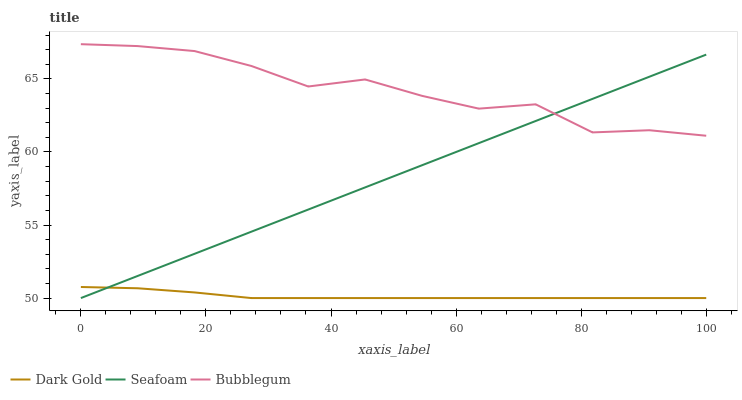Does Dark Gold have the minimum area under the curve?
Answer yes or no. Yes. Does Bubblegum have the maximum area under the curve?
Answer yes or no. Yes. Does Bubblegum have the minimum area under the curve?
Answer yes or no. No. Does Dark Gold have the maximum area under the curve?
Answer yes or no. No. Is Seafoam the smoothest?
Answer yes or no. Yes. Is Bubblegum the roughest?
Answer yes or no. Yes. Is Dark Gold the smoothest?
Answer yes or no. No. Is Dark Gold the roughest?
Answer yes or no. No. Does Seafoam have the lowest value?
Answer yes or no. Yes. Does Bubblegum have the lowest value?
Answer yes or no. No. Does Bubblegum have the highest value?
Answer yes or no. Yes. Does Dark Gold have the highest value?
Answer yes or no. No. Is Dark Gold less than Bubblegum?
Answer yes or no. Yes. Is Bubblegum greater than Dark Gold?
Answer yes or no. Yes. Does Bubblegum intersect Seafoam?
Answer yes or no. Yes. Is Bubblegum less than Seafoam?
Answer yes or no. No. Is Bubblegum greater than Seafoam?
Answer yes or no. No. Does Dark Gold intersect Bubblegum?
Answer yes or no. No. 